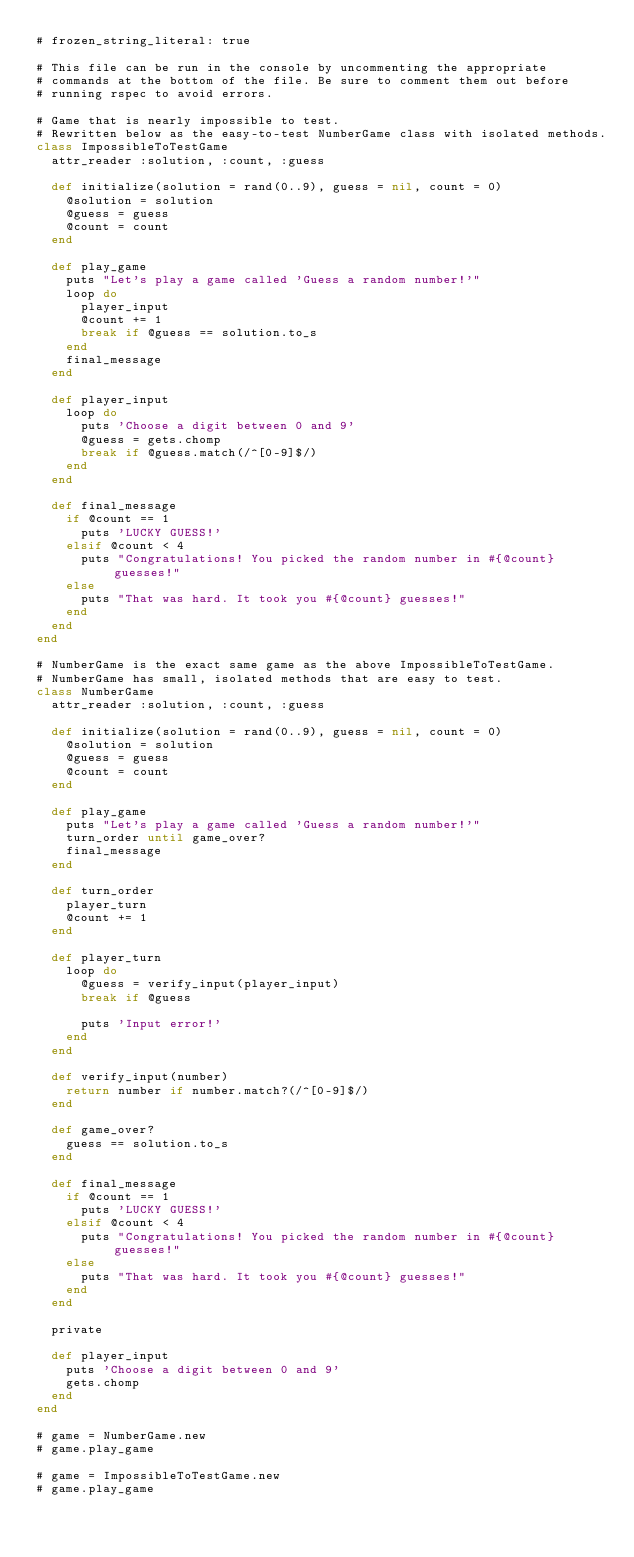<code> <loc_0><loc_0><loc_500><loc_500><_Ruby_># frozen_string_literal: true

# This file can be run in the console by uncommenting the appropriate
# commands at the bottom of the file. Be sure to comment them out before
# running rspec to avoid errors.

# Game that is nearly impossible to test.
# Rewritten below as the easy-to-test NumberGame class with isolated methods.
class ImpossibleToTestGame
  attr_reader :solution, :count, :guess

  def initialize(solution = rand(0..9), guess = nil, count = 0)
    @solution = solution
    @guess = guess
    @count = count
  end

  def play_game
    puts "Let's play a game called 'Guess a random number!'"
    loop do
      player_input
      @count += 1
      break if @guess == solution.to_s
    end
    final_message
  end

  def player_input
    loop do
      puts 'Choose a digit between 0 and 9'
      @guess = gets.chomp
      break if @guess.match(/^[0-9]$/)
    end
  end

  def final_message
    if @count == 1
      puts 'LUCKY GUESS!'
    elsif @count < 4
      puts "Congratulations! You picked the random number in #{@count} guesses!"
    else
      puts "That was hard. It took you #{@count} guesses!"
    end
  end
end

# NumberGame is the exact same game as the above ImpossibleToTestGame.
# NumberGame has small, isolated methods that are easy to test.
class NumberGame
  attr_reader :solution, :count, :guess

  def initialize(solution = rand(0..9), guess = nil, count = 0)
    @solution = solution
    @guess = guess
    @count = count
  end

  def play_game
    puts "Let's play a game called 'Guess a random number!'"
    turn_order until game_over?
    final_message
  end

  def turn_order
    player_turn
    @count += 1
  end

  def player_turn
    loop do
      @guess = verify_input(player_input)
      break if @guess

      puts 'Input error!'
    end
  end

  def verify_input(number)
    return number if number.match?(/^[0-9]$/)
  end

  def game_over?
    guess == solution.to_s
  end

  def final_message
    if @count == 1
      puts 'LUCKY GUESS!'
    elsif @count < 4
      puts "Congratulations! You picked the random number in #{@count} guesses!"
    else
      puts "That was hard. It took you #{@count} guesses!"
    end
  end

  private

  def player_input
    puts 'Choose a digit between 0 and 9'
    gets.chomp
  end
end

# game = NumberGame.new
# game.play_game

# game = ImpossibleToTestGame.new
# game.play_game
</code> 